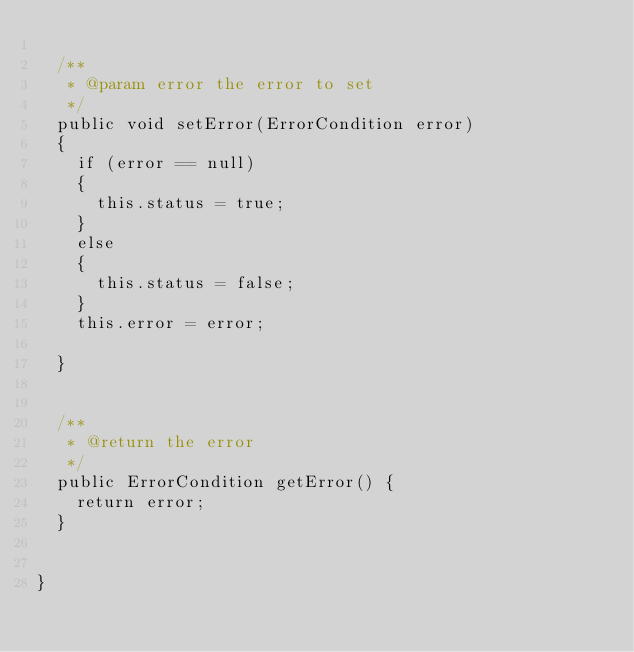<code> <loc_0><loc_0><loc_500><loc_500><_Java_>
	/**
	 * @param error the error to set
	 */
	public void setError(ErrorCondition error) 
	{
		if (error == null)
		{
			this.status = true;
		}
		else
		{
			this.status = false;
		}
		this.error = error;
		
	}


	/**
	 * @return the error
	 */
	public ErrorCondition getError() {
		return error;
	}
	

}
</code> 